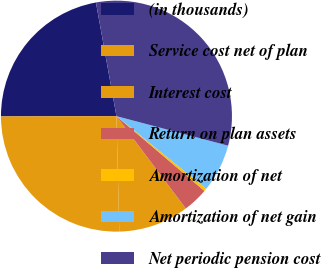<chart> <loc_0><loc_0><loc_500><loc_500><pie_chart><fcel>(in thousands)<fcel>Service cost net of plan<fcel>Interest cost<fcel>Return on plan assets<fcel>Amortization of net<fcel>Amortization of net gain<fcel>Net periodic pension cost<nl><fcel>22.19%<fcel>25.35%<fcel>9.86%<fcel>3.54%<fcel>0.39%<fcel>6.7%<fcel>31.96%<nl></chart> 